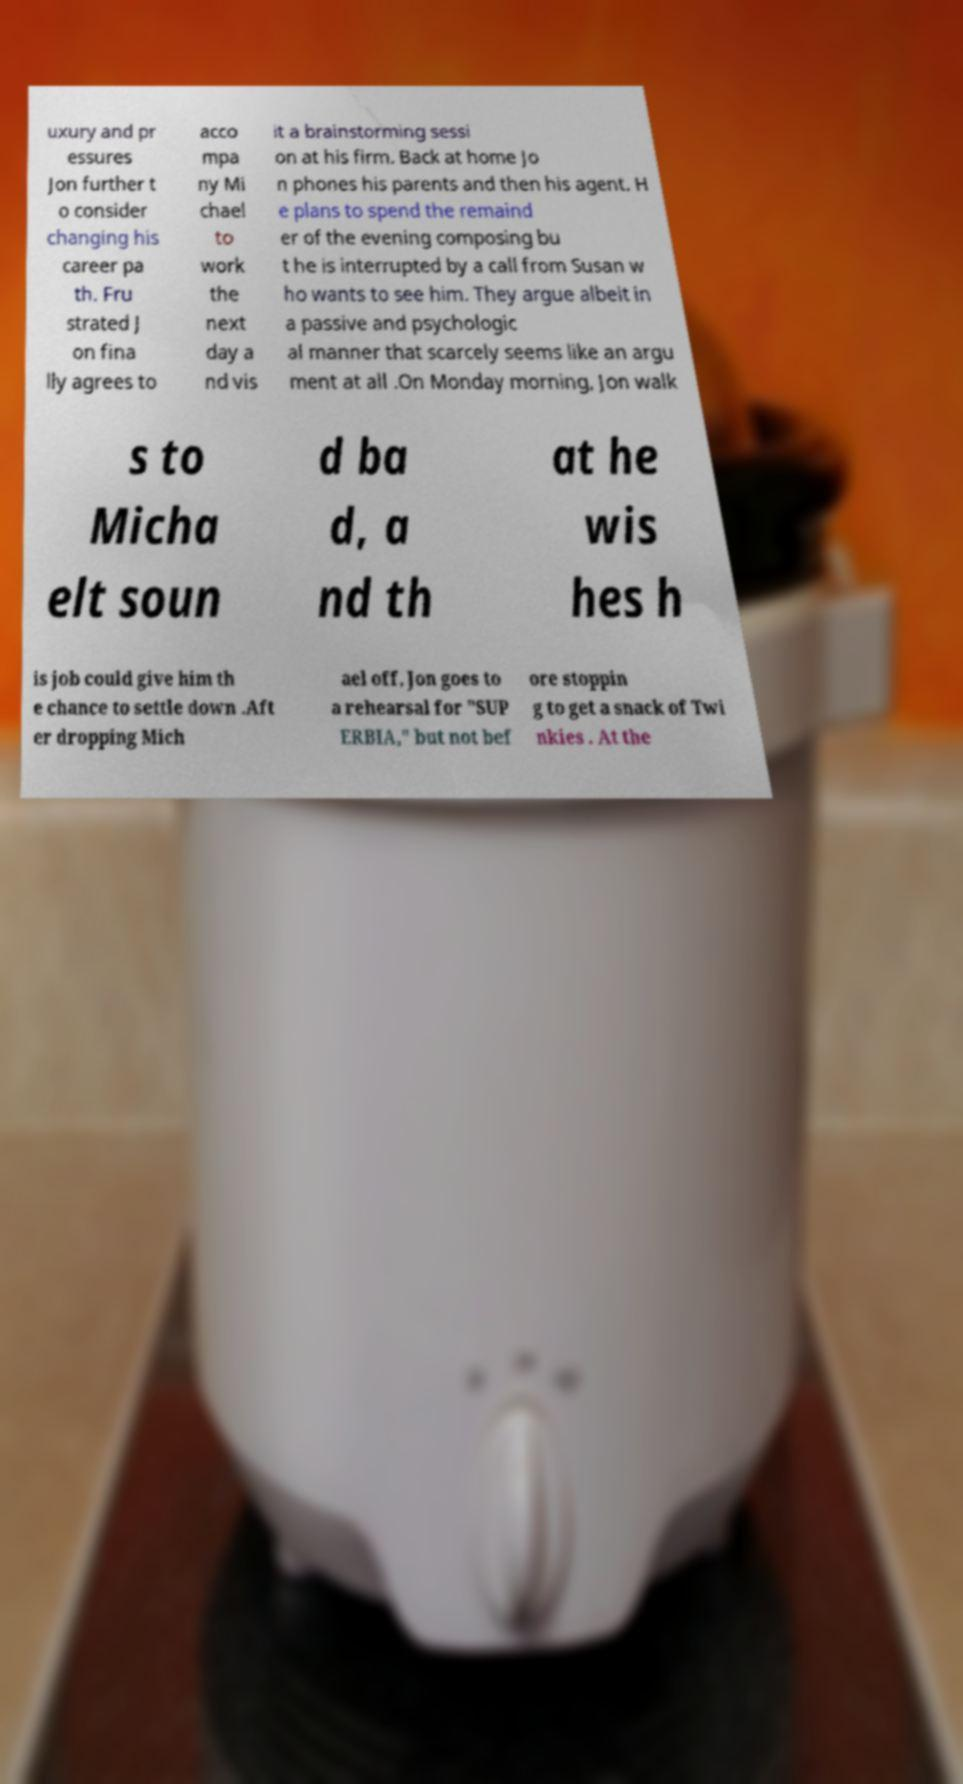There's text embedded in this image that I need extracted. Can you transcribe it verbatim? uxury and pr essures Jon further t o consider changing his career pa th. Fru strated J on fina lly agrees to acco mpa ny Mi chael to work the next day a nd vis it a brainstorming sessi on at his firm. Back at home Jo n phones his parents and then his agent. H e plans to spend the remaind er of the evening composing bu t he is interrupted by a call from Susan w ho wants to see him. They argue albeit in a passive and psychologic al manner that scarcely seems like an argu ment at all .On Monday morning, Jon walk s to Micha elt soun d ba d, a nd th at he wis hes h is job could give him th e chance to settle down .Aft er dropping Mich ael off, Jon goes to a rehearsal for "SUP ERBIA," but not bef ore stoppin g to get a snack of Twi nkies . At the 